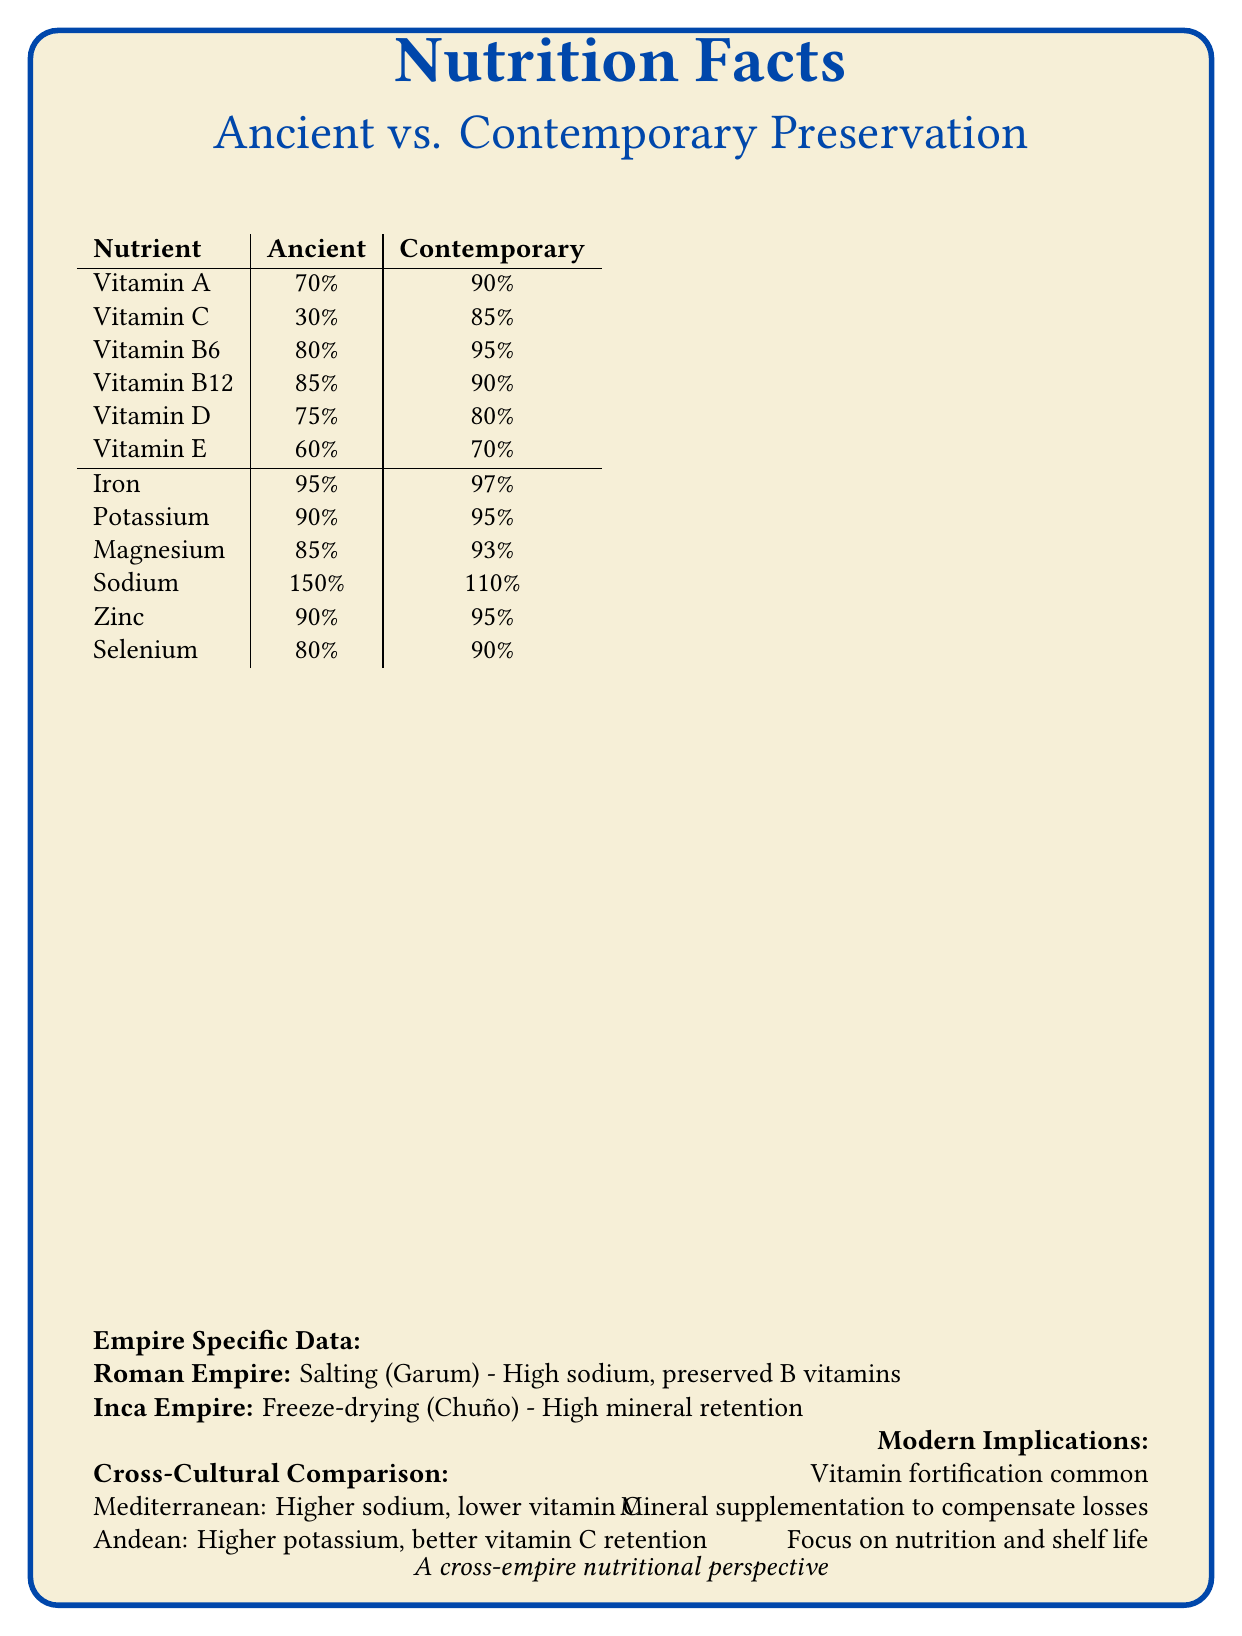What is the vitamin retention percentage of Vitamin A in contemporary preservation methods? According to the table in the document, the vitamin retention percentage of Vitamin A in contemporary preservation methods is 90%.
Answer: 90% Which mineral shows the highest retention in both ancient and contemporary preservation methods? A. Iron B. Potassium C. Magnesium D. Zinc Both the ancient (95%) and contemporary (97%) preservation methods show that Iron has the highest retention among the listed minerals.
Answer: A. Iron How does the sodium content compare between ancient and contemporary preservation methods? The document shows that the sodium content in ancient preservation methods is higher (150%) compared to contemporary methods (110%).
Answer: Ancient: 150%, Contemporary: 110% Which empire primarily used salting as their preservation method? According to the Empire Specific Data section, the Roman Empire primarily used salting, especially for Garum, a fermented fish sauce.
Answer: Roman Empire What is a major nutritional impact of freeze-drying used by the Inca Empire? The Empire Specific Data section indicates that freeze-drying (Chuño) used by the Inca Empire resulted in high mineral retention.
Answer: High retention of minerals Which preservation method is associated with higher potassium retention? A. Salting B. Freeze-drying C. Canning D. Sun drying The Cross-Cultural Comparison indicates that Andean methods, which include freeze-drying, have higher potassium retention compared to Mediterranean methods.
Answer: B. Freeze-drying Is vitamin fortification common in modern food preservation for long-distance transportation? The Modern Implications section states that vitamin fortification is common in long-distance transported foods.
Answer: Yes Summarize the main idea of the document in one sentence. The document provides a comprehensive comparison of nutrient retention in ancient and modern food preservation methods, highlights specific practices in historical empires, and discusses contemporary implications for global food trade.
Answer: The document compares the vitamin and mineral retention of ancient and contemporary preservation methods and examines their impacts on historical and modern food transportation. What is the nutritional impact of the most transported food in the Roman Empire? The Empire Specific Data section states that Garum, the most transported food in the Roman Empire, had a high sodium content and preserved B vitamins.
Answer: High sodium content, preserved B vitamins Which vitamin shows the greatest improvement in retention from ancient to contemporary preservation methods? A. Vitamin A B. Vitamin C C. Vitamin B12 D. Vitamin D According to the table, Vitamin C retention increases from 30% in ancient methods to 85% in contemporary methods, showing the greatest improvement.
Answer: B. Vitamin C What cross-cultural comparison can be made regarding vitamin C retention between Mediterranean and Andean practices? The Cross-Cultural Comparison section indicates that Andean preservation methods result in better Vitamin C retention compared to Mediterranean methods.
Answer: Andean methods have higher Vitamin C retention Does the document specify the exact amount of sodium in contemporary preservation methods? The document provides the percentage retention of sodium (110%) but does not specify the exact amount of sodium in contemporary preservation methods.
Answer: No Can you determine the specific foods preserved by each contemporary method from the given document? The document lists specific foods under contemporary preservation methods: freeze-drying preserves berries, vegetables, and meat; canning preserves tomatoes, beans, and tuna.
Answer: Yes 